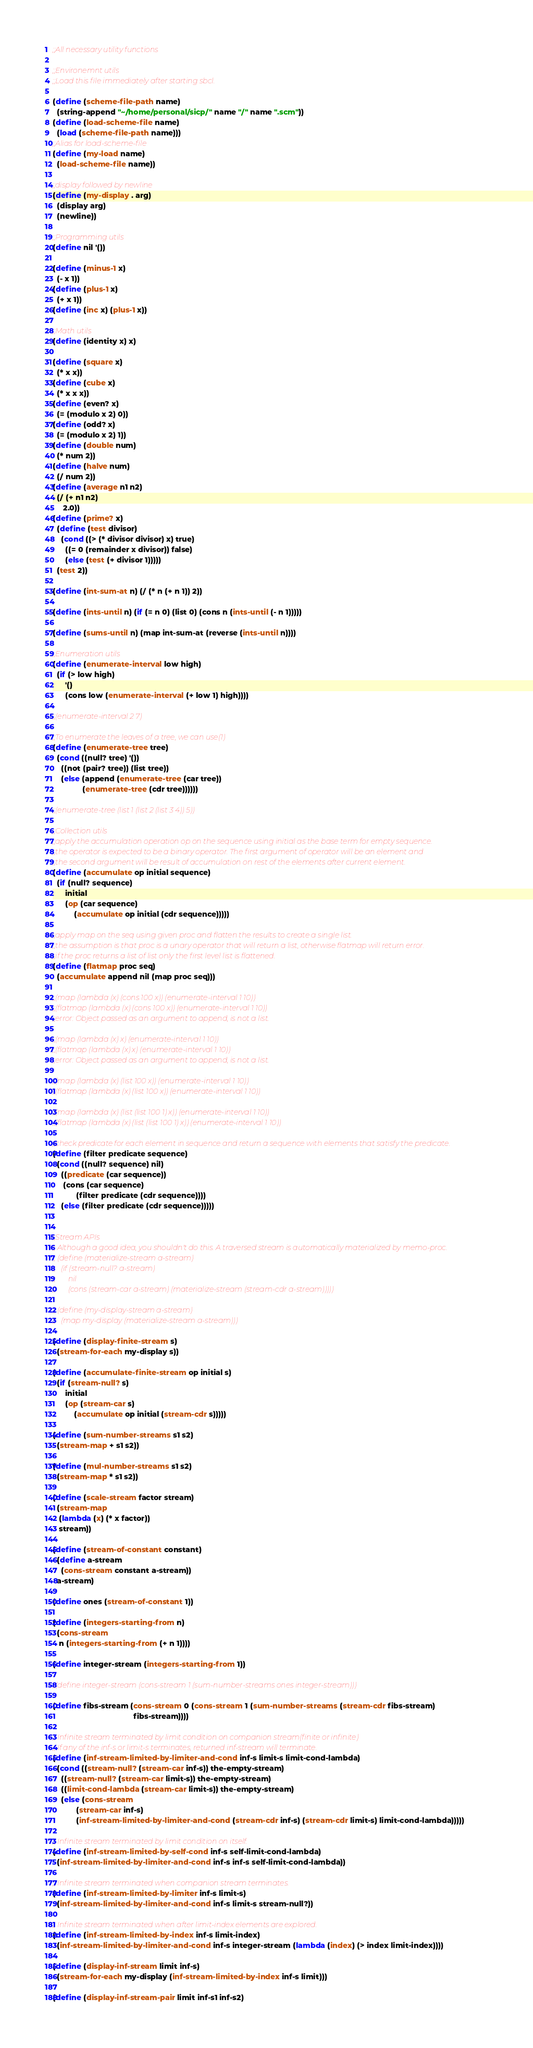Convert code to text. <code><loc_0><loc_0><loc_500><loc_500><_Scheme_>;;All necessary utility functions

;;Environemnt utils
;;Load this file immediately after starting sbcl.

(define (scheme-file-path name)
  (string-append "~/home/personal/sicp/" name "/" name ".scm"))
(define (load-scheme-file name)
  (load (scheme-file-path name)))
;;Alias for load-scheme-file
(define (my-load name)
  (load-scheme-file name))

;;display followed by newline
(define (my-display . arg)
  (display arg)
  (newline))

;;Programming utils
(define nil '())

(define (minus-1 x)
  (- x 1))
(define (plus-1 x)
  (+ x 1))
(define (inc x) (plus-1 x))

;;Math utils
(define (identity x) x)

(define (square x)
  (* x x))
(define (cube x)
  (* x x x))
(define (even? x)
  (= (modulo x 2) 0))
(define (odd? x)
  (= (modulo x 2) 1))
(define (double num)
  (* num 2))
(define (halve num)
  (/ num 2))
(define (average n1 n2)
  (/ (+ n1 n2)
     2.0))
(define (prime? x)
  (define (test divisor)
    (cond ((> (* divisor divisor) x) true)
	  ((= 0 (remainder x divisor)) false)
	  (else (test (+ divisor 1)))))
  (test 2))

(define (int-sum-at n) (/ (* n (+ n 1)) 2))

(define (ints-until n) (if (= n 0) (list 0) (cons n (ints-until (- n 1)))))

(define (sums-until n) (map int-sum-at (reverse (ints-until n))))

;;Enumeration utils
(define (enumerate-interval low high)
  (if (> low high)
      '()
      (cons low (enumerate-interval (+ low 1) high))))

;;(enumerate-interval 2 7)

;;To enumerate the leaves of a tree, we can use(1)
(define (enumerate-tree tree)
  (cond ((null? tree) '())
	((not (pair? tree)) (list tree))
	(else (append (enumerate-tree (car tree))
		      (enumerate-tree (cdr tree))))))

;;(enumerate-tree (list 1 (list 2 (list 3 4)) 5))

;;Collection utils
;;apply the accumulation operation op on the sequence using initial as the base term for empty sequence.
;;the operator is expected to be a binary operator. The first argument of operator will be an element and
;;the second argument will be result of accumulation on rest of the elements after current element.
(define (accumulate op initial sequence)
  (if (null? sequence)
      initial
      (op (car sequence)
          (accumulate op initial (cdr sequence)))))

;;apply map on the seq using given proc and flatten the results to create a single list.
;;the assumption is that proc is a unary operator that will return a list, otherwise flatmap will return error.
;;if the proc returns a list of list only the first level list is flattened.
(define (flatmap proc seq)
  (accumulate append nil (map proc seq)))

;;(map (lambda (x) (cons 100 x)) (enumerate-interval 1 10))
;;(flatmap (lambda (x) (cons 100 x)) (enumerate-interval 1 10))
;;error: Object passed as an argument to append, is not a list.

;;(map (lambda (x) x) (enumerate-interval 1 10))
;;(flatmap (lambda (x) x) (enumerate-interval 1 10))
;;error: Object passed as an argument to append, is not a list.

;;(map (lambda (x) (list 100 x)) (enumerate-interval 1 10))
;;(flatmap (lambda (x) (list 100 x)) (enumerate-interval 1 10))

;;(map (lambda (x) (list (list 100 1) x)) (enumerate-interval 1 10))
;;(flatmap (lambda (x) (list (list 100 1) x)) (enumerate-interval 1 10))

;;check predicate for each element in sequence and return a sequence with elements that satisfy the predicate.
(define (filter predicate sequence)
  (cond ((null? sequence) nil)
	((predicate (car sequence))
	 (cons (car sequence)
	       (filter predicate (cdr sequence))))
	(else (filter predicate (cdr sequence)))))


;;Stream APIs
;; Although a good idea, you shouldn't do this. A traversed stream is automatically materialized by memo-proc.
;; (define (materialize-stream a-stream)
;;   (if (stream-null? a-stream)
;;       nil
;;       (cons (stream-car a-stream) (materialize-stream (stream-cdr a-stream)))))

;; (define (my-display-stream a-stream)
;;   (map my-display (materialize-stream a-stream)))

(define (display-finite-stream s)
  (stream-for-each my-display s))

(define (accumulate-finite-stream op initial s)
  (if (stream-null? s)
      initial
      (op (stream-car s)
          (accumulate op initial (stream-cdr s)))))

(define (sum-number-streams s1 s2)
  (stream-map + s1 s2))

(define (mul-number-streams s1 s2)
  (stream-map * s1 s2))

(define (scale-stream factor stream)
  (stream-map
   (lambda (x) (* x factor))
   stream))

(define (stream-of-constant constant)
  (define a-stream
    (cons-stream constant a-stream))
  a-stream)

(define ones (stream-of-constant 1))

(define (integers-starting-from n)
  (cons-stream 
   n (integers-starting-from (+ n 1))))

(define integer-stream (integers-starting-from 1))

;;(define integer-stream (cons-stream 1 (sum-number-streams ones integer-stream)))

(define fibs-stream (cons-stream 0 (cons-stream 1 (sum-number-streams (stream-cdr fibs-stream)
								      fibs-stream))))

;; Infinite stream terminated by limit condition on companion stream(finite or infinite)
;; If any of the inf-s or limit-s terminates, returned inf-stream will terminate.
(define (inf-stream-limited-by-limiter-and-cond inf-s limit-s limit-cond-lambda)
  (cond ((stream-null? (stream-car inf-s)) the-empty-stream)
	((stream-null? (stream-car limit-s)) the-empty-stream)
	((limit-cond-lambda (stream-car limit-s)) the-empty-stream)
	(else (cons-stream
	       (stream-car inf-s)
	       (inf-stream-limited-by-limiter-and-cond (stream-cdr inf-s) (stream-cdr limit-s) limit-cond-lambda)))))

;; Infinite stream terminated by limit condition on itself.
(define (inf-stream-limited-by-self-cond inf-s self-limit-cond-lambda)
  (inf-stream-limited-by-limiter-and-cond inf-s inf-s self-limit-cond-lambda))

;; Infinite stream terminated when companion stream terminates.
(define (inf-stream-limited-by-limiter inf-s limit-s)
  (inf-stream-limited-by-limiter-and-cond inf-s limit-s stream-null?))

;; Infinite stream terminated when after limit-index elements are explored.
(define (inf-stream-limited-by-index inf-s limit-index)
  (inf-stream-limited-by-limiter-and-cond inf-s integer-stream (lambda (index) (> index limit-index))))

(define (display-inf-stream limit inf-s)
  (stream-for-each my-display (inf-stream-limited-by-index inf-s limit)))

(define (display-inf-stream-pair limit inf-s1 inf-s2)</code> 